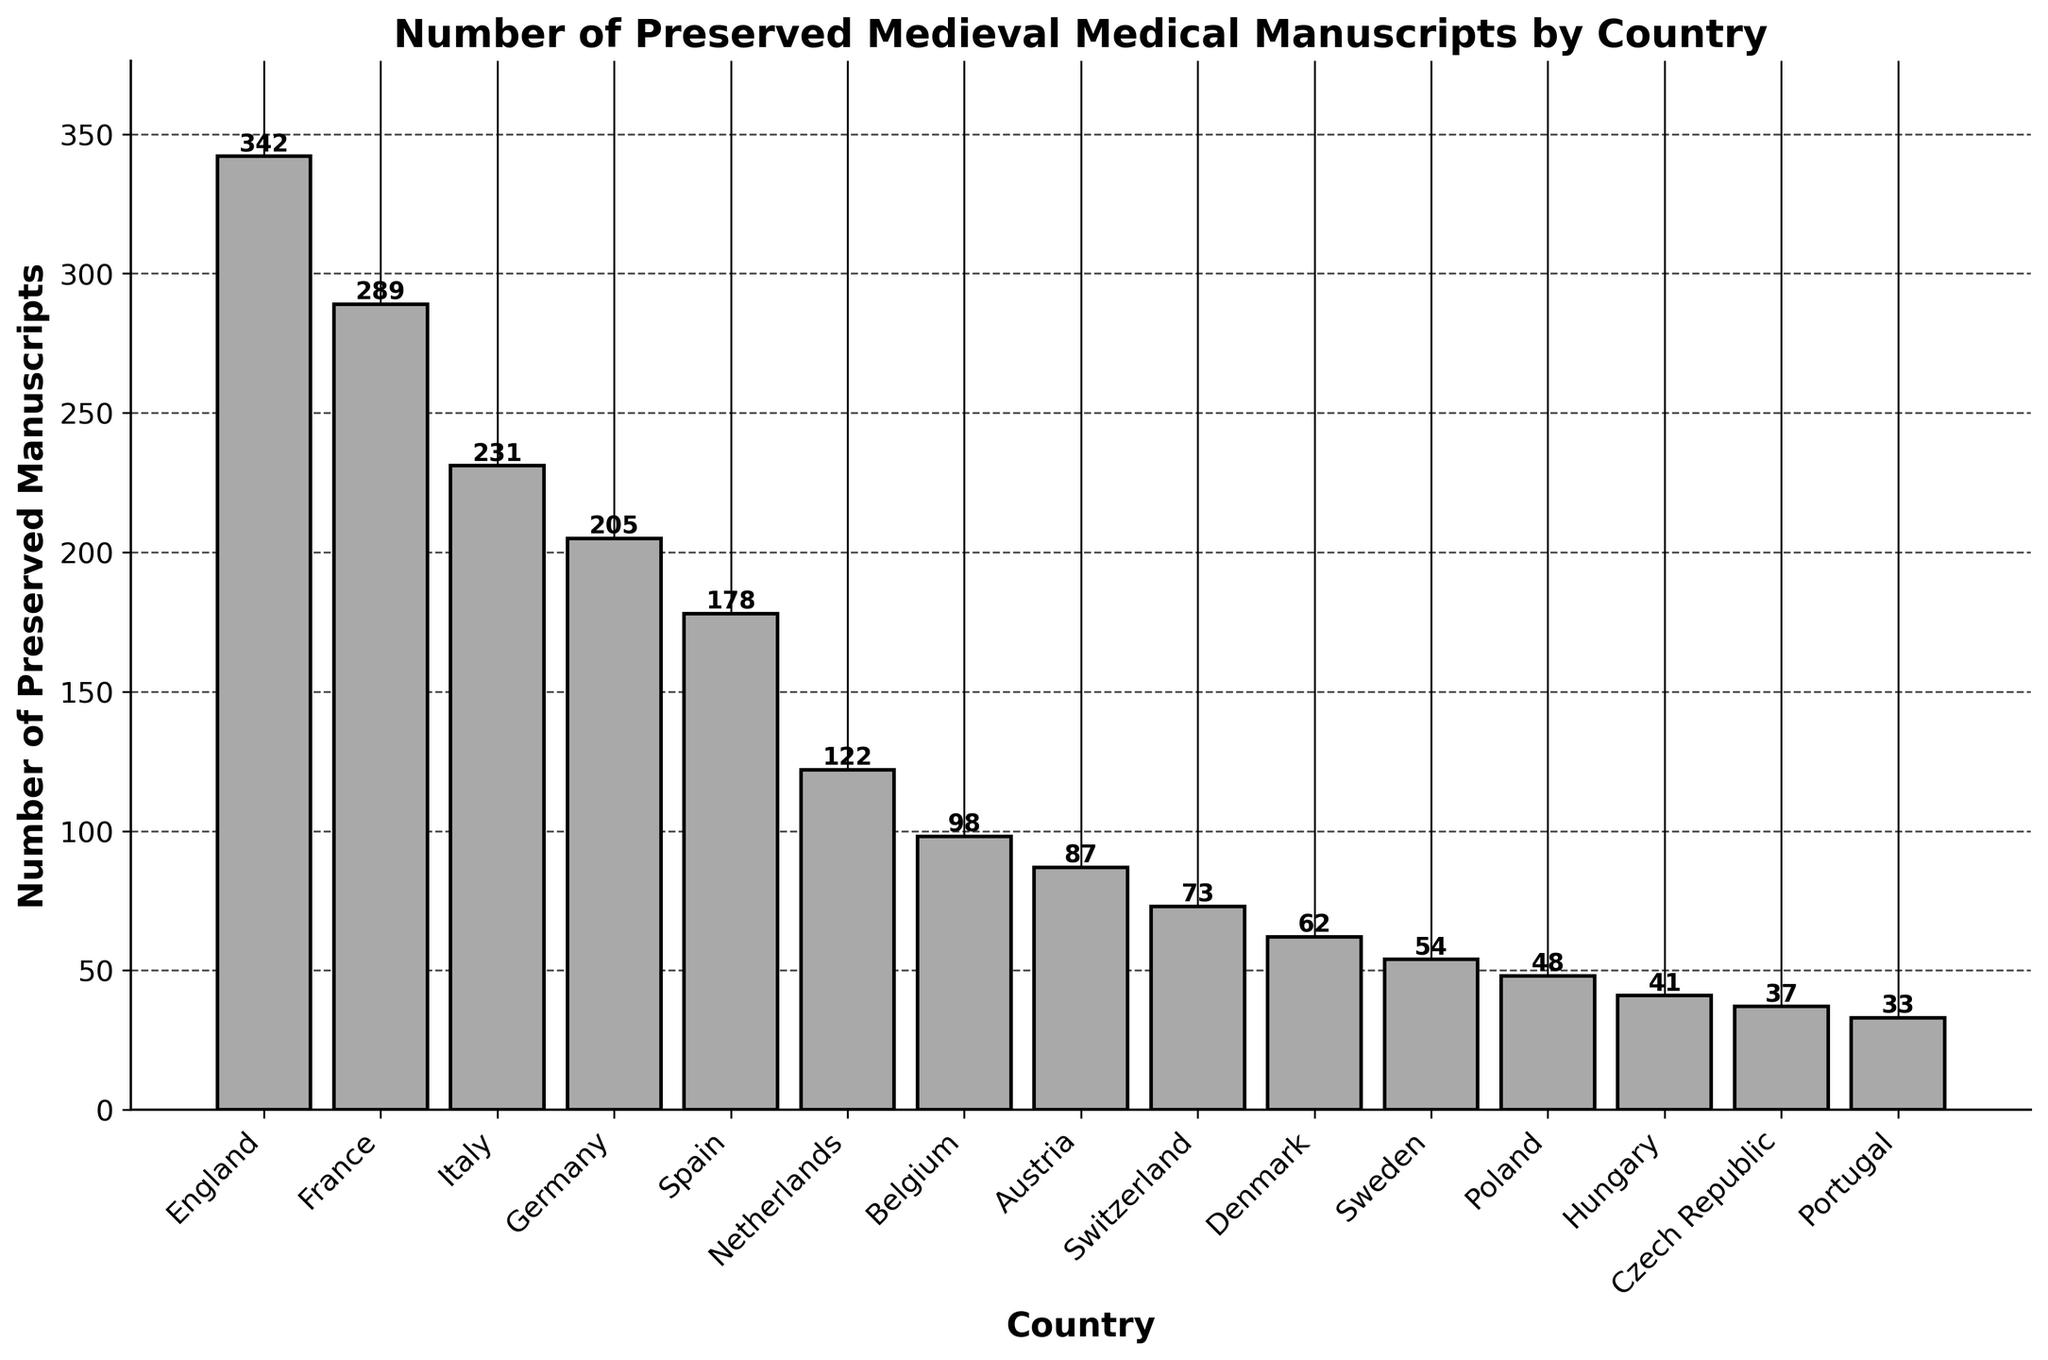Which country has the highest number of preserved medical manuscripts? The figure shows the number of preserved medical manuscripts for each country, with the bar for England being the tallest, indicating the highest number.
Answer: England What is the difference in the number of manuscripts between England and France? The number of manuscripts for England is 342, and for France, it is 289. The difference is calculated as 342 - 289.
Answer: 53 Which two countries have the closest number of preserved manuscripts, and what are their respective counts? The graph shows that the bars for Belgium and Austria are very close in height. Belgium has 98 manuscripts, and Austria has 87.
Answer: Belgium (98) and Austria (87) How many more manuscripts does Italy have compared to Spain? The number of manuscripts for Italy is 231, and for Spain, it is 178. The difference is 231 - 178.
Answer: 53 What is the combined total number of manuscripts for Germany, Spain, and the Netherlands? Add the number of manuscripts for Germany (205), Spain (178), and the Netherlands (122): 205 + 178 + 122.
Answer: 505 How many countries have more than 200 preserved manuscripts? The graph shows four bars above the 200 mark: England, France, Italy, and Germany.
Answer: 4 Which country has the fewest preserved medieval medical manuscripts, and how many are there? The shortest bar belongs to Portugal, indicating 33 manuscripts.
Answer: Portugal (33) What is the average number of preserved manuscripts across all the countries listed? Sum all the manuscript counts (342 + 289 + 231 + 205 + 178 + 122 + 98 + 87 + 73 + 62 + 54 + 48 + 41 + 37 + 33) and divide by the number of countries (15). Total = 1900. Average = 1900 / 15.
Answer: 126.67 How does the total number of manuscripts for Scandinavia (Denmark and Sweden) compare to that of Poland? Denmark has 62 manuscripts, and Sweden has 54. The combined total for Scandinavia is 62 + 54 = 116. Poland has 48 manuscripts.
Answer: Scandinavia: 116, Poland: 48 